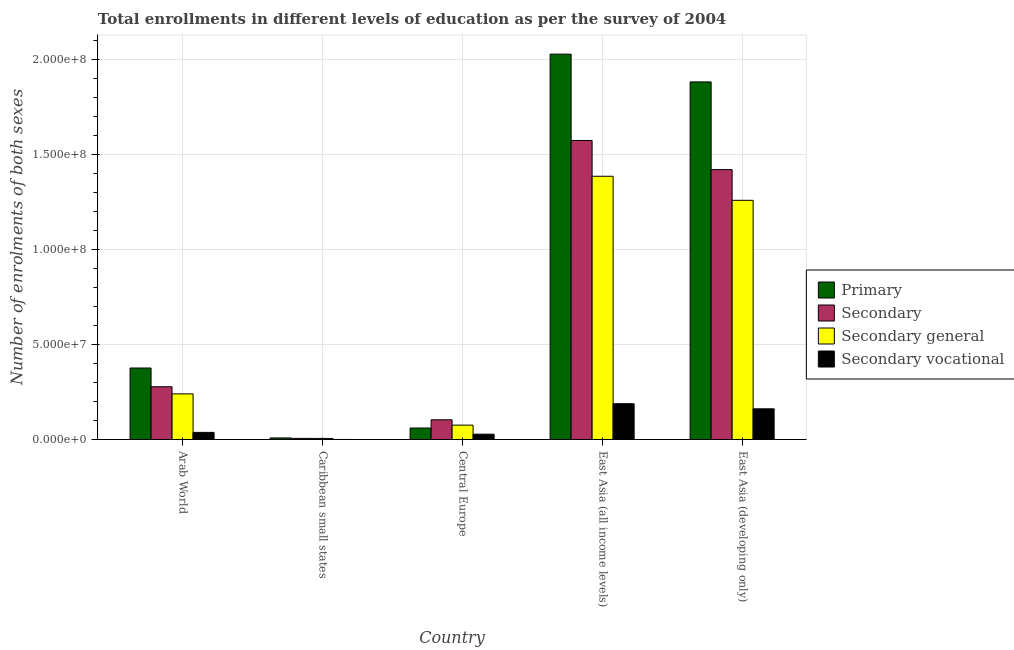Are the number of bars per tick equal to the number of legend labels?
Provide a succinct answer. Yes. How many bars are there on the 4th tick from the left?
Provide a succinct answer. 4. What is the label of the 3rd group of bars from the left?
Offer a terse response. Central Europe. In how many cases, is the number of bars for a given country not equal to the number of legend labels?
Your answer should be compact. 0. What is the number of enrolments in secondary education in Central Europe?
Your answer should be very brief. 1.04e+07. Across all countries, what is the maximum number of enrolments in secondary vocational education?
Your answer should be very brief. 1.88e+07. Across all countries, what is the minimum number of enrolments in secondary vocational education?
Your response must be concise. 3.11e+04. In which country was the number of enrolments in secondary vocational education maximum?
Make the answer very short. East Asia (all income levels). In which country was the number of enrolments in secondary education minimum?
Your answer should be very brief. Caribbean small states. What is the total number of enrolments in secondary education in the graph?
Your response must be concise. 3.38e+08. What is the difference between the number of enrolments in secondary general education in Central Europe and that in East Asia (all income levels)?
Provide a succinct answer. -1.31e+08. What is the difference between the number of enrolments in secondary general education in East Asia (all income levels) and the number of enrolments in secondary education in Arab World?
Provide a short and direct response. 1.11e+08. What is the average number of enrolments in primary education per country?
Ensure brevity in your answer.  8.71e+07. What is the difference between the number of enrolments in secondary vocational education and number of enrolments in primary education in Caribbean small states?
Make the answer very short. -8.08e+05. What is the ratio of the number of enrolments in secondary education in Caribbean small states to that in East Asia (all income levels)?
Provide a succinct answer. 0. Is the number of enrolments in primary education in Central Europe less than that in East Asia (developing only)?
Keep it short and to the point. Yes. What is the difference between the highest and the second highest number of enrolments in secondary vocational education?
Your response must be concise. 2.68e+06. What is the difference between the highest and the lowest number of enrolments in secondary education?
Provide a succinct answer. 1.57e+08. Is it the case that in every country, the sum of the number of enrolments in primary education and number of enrolments in secondary general education is greater than the sum of number of enrolments in secondary education and number of enrolments in secondary vocational education?
Keep it short and to the point. No. What does the 3rd bar from the left in Arab World represents?
Give a very brief answer. Secondary general. What does the 1st bar from the right in Central Europe represents?
Make the answer very short. Secondary vocational. Is it the case that in every country, the sum of the number of enrolments in primary education and number of enrolments in secondary education is greater than the number of enrolments in secondary general education?
Offer a very short reply. Yes. Are all the bars in the graph horizontal?
Your answer should be compact. No. Where does the legend appear in the graph?
Your answer should be compact. Center right. What is the title of the graph?
Give a very brief answer. Total enrollments in different levels of education as per the survey of 2004. Does "Secondary schools" appear as one of the legend labels in the graph?
Provide a succinct answer. No. What is the label or title of the X-axis?
Your answer should be compact. Country. What is the label or title of the Y-axis?
Your response must be concise. Number of enrolments of both sexes. What is the Number of enrolments of both sexes in Primary in Arab World?
Keep it short and to the point. 3.76e+07. What is the Number of enrolments of both sexes in Secondary in Arab World?
Make the answer very short. 2.78e+07. What is the Number of enrolments of both sexes of Secondary general in Arab World?
Provide a short and direct response. 2.40e+07. What is the Number of enrolments of both sexes of Secondary vocational in Arab World?
Your response must be concise. 3.75e+06. What is the Number of enrolments of both sexes in Primary in Caribbean small states?
Make the answer very short. 8.39e+05. What is the Number of enrolments of both sexes in Secondary in Caribbean small states?
Your answer should be very brief. 5.95e+05. What is the Number of enrolments of both sexes in Secondary general in Caribbean small states?
Ensure brevity in your answer.  5.64e+05. What is the Number of enrolments of both sexes of Secondary vocational in Caribbean small states?
Your answer should be very brief. 3.11e+04. What is the Number of enrolments of both sexes of Primary in Central Europe?
Ensure brevity in your answer.  6.05e+06. What is the Number of enrolments of both sexes of Secondary in Central Europe?
Offer a very short reply. 1.04e+07. What is the Number of enrolments of both sexes of Secondary general in Central Europe?
Keep it short and to the point. 7.57e+06. What is the Number of enrolments of both sexes of Secondary vocational in Central Europe?
Keep it short and to the point. 2.81e+06. What is the Number of enrolments of both sexes in Primary in East Asia (all income levels)?
Offer a very short reply. 2.03e+08. What is the Number of enrolments of both sexes in Secondary in East Asia (all income levels)?
Make the answer very short. 1.57e+08. What is the Number of enrolments of both sexes of Secondary general in East Asia (all income levels)?
Your answer should be very brief. 1.39e+08. What is the Number of enrolments of both sexes of Secondary vocational in East Asia (all income levels)?
Give a very brief answer. 1.88e+07. What is the Number of enrolments of both sexes of Primary in East Asia (developing only)?
Give a very brief answer. 1.88e+08. What is the Number of enrolments of both sexes of Secondary in East Asia (developing only)?
Your answer should be compact. 1.42e+08. What is the Number of enrolments of both sexes in Secondary general in East Asia (developing only)?
Your answer should be compact. 1.26e+08. What is the Number of enrolments of both sexes of Secondary vocational in East Asia (developing only)?
Provide a succinct answer. 1.62e+07. Across all countries, what is the maximum Number of enrolments of both sexes in Primary?
Offer a terse response. 2.03e+08. Across all countries, what is the maximum Number of enrolments of both sexes of Secondary?
Provide a succinct answer. 1.57e+08. Across all countries, what is the maximum Number of enrolments of both sexes of Secondary general?
Keep it short and to the point. 1.39e+08. Across all countries, what is the maximum Number of enrolments of both sexes of Secondary vocational?
Your answer should be compact. 1.88e+07. Across all countries, what is the minimum Number of enrolments of both sexes of Primary?
Make the answer very short. 8.39e+05. Across all countries, what is the minimum Number of enrolments of both sexes of Secondary?
Your answer should be very brief. 5.95e+05. Across all countries, what is the minimum Number of enrolments of both sexes in Secondary general?
Make the answer very short. 5.64e+05. Across all countries, what is the minimum Number of enrolments of both sexes in Secondary vocational?
Your response must be concise. 3.11e+04. What is the total Number of enrolments of both sexes in Primary in the graph?
Your answer should be compact. 4.35e+08. What is the total Number of enrolments of both sexes of Secondary in the graph?
Provide a succinct answer. 3.38e+08. What is the total Number of enrolments of both sexes in Secondary general in the graph?
Provide a succinct answer. 2.97e+08. What is the total Number of enrolments of both sexes of Secondary vocational in the graph?
Give a very brief answer. 4.16e+07. What is the difference between the Number of enrolments of both sexes in Primary in Arab World and that in Caribbean small states?
Give a very brief answer. 3.68e+07. What is the difference between the Number of enrolments of both sexes in Secondary in Arab World and that in Caribbean small states?
Your answer should be very brief. 2.72e+07. What is the difference between the Number of enrolments of both sexes in Secondary general in Arab World and that in Caribbean small states?
Offer a very short reply. 2.35e+07. What is the difference between the Number of enrolments of both sexes of Secondary vocational in Arab World and that in Caribbean small states?
Offer a very short reply. 3.72e+06. What is the difference between the Number of enrolments of both sexes of Primary in Arab World and that in Central Europe?
Make the answer very short. 3.16e+07. What is the difference between the Number of enrolments of both sexes in Secondary in Arab World and that in Central Europe?
Provide a succinct answer. 1.74e+07. What is the difference between the Number of enrolments of both sexes of Secondary general in Arab World and that in Central Europe?
Give a very brief answer. 1.65e+07. What is the difference between the Number of enrolments of both sexes of Secondary vocational in Arab World and that in Central Europe?
Offer a terse response. 9.45e+05. What is the difference between the Number of enrolments of both sexes in Primary in Arab World and that in East Asia (all income levels)?
Provide a succinct answer. -1.65e+08. What is the difference between the Number of enrolments of both sexes in Secondary in Arab World and that in East Asia (all income levels)?
Your answer should be very brief. -1.30e+08. What is the difference between the Number of enrolments of both sexes in Secondary general in Arab World and that in East Asia (all income levels)?
Provide a short and direct response. -1.14e+08. What is the difference between the Number of enrolments of both sexes in Secondary vocational in Arab World and that in East Asia (all income levels)?
Provide a short and direct response. -1.51e+07. What is the difference between the Number of enrolments of both sexes in Primary in Arab World and that in East Asia (developing only)?
Offer a terse response. -1.51e+08. What is the difference between the Number of enrolments of both sexes in Secondary in Arab World and that in East Asia (developing only)?
Give a very brief answer. -1.14e+08. What is the difference between the Number of enrolments of both sexes in Secondary general in Arab World and that in East Asia (developing only)?
Provide a succinct answer. -1.02e+08. What is the difference between the Number of enrolments of both sexes in Secondary vocational in Arab World and that in East Asia (developing only)?
Provide a short and direct response. -1.24e+07. What is the difference between the Number of enrolments of both sexes in Primary in Caribbean small states and that in Central Europe?
Give a very brief answer. -5.21e+06. What is the difference between the Number of enrolments of both sexes in Secondary in Caribbean small states and that in Central Europe?
Provide a short and direct response. -9.78e+06. What is the difference between the Number of enrolments of both sexes of Secondary general in Caribbean small states and that in Central Europe?
Offer a terse response. -7.01e+06. What is the difference between the Number of enrolments of both sexes in Secondary vocational in Caribbean small states and that in Central Europe?
Keep it short and to the point. -2.78e+06. What is the difference between the Number of enrolments of both sexes in Primary in Caribbean small states and that in East Asia (all income levels)?
Your response must be concise. -2.02e+08. What is the difference between the Number of enrolments of both sexes of Secondary in Caribbean small states and that in East Asia (all income levels)?
Your response must be concise. -1.57e+08. What is the difference between the Number of enrolments of both sexes in Secondary general in Caribbean small states and that in East Asia (all income levels)?
Your answer should be very brief. -1.38e+08. What is the difference between the Number of enrolments of both sexes in Secondary vocational in Caribbean small states and that in East Asia (all income levels)?
Offer a terse response. -1.88e+07. What is the difference between the Number of enrolments of both sexes of Primary in Caribbean small states and that in East Asia (developing only)?
Your answer should be very brief. -1.87e+08. What is the difference between the Number of enrolments of both sexes in Secondary in Caribbean small states and that in East Asia (developing only)?
Keep it short and to the point. -1.41e+08. What is the difference between the Number of enrolments of both sexes of Secondary general in Caribbean small states and that in East Asia (developing only)?
Make the answer very short. -1.25e+08. What is the difference between the Number of enrolments of both sexes in Secondary vocational in Caribbean small states and that in East Asia (developing only)?
Ensure brevity in your answer.  -1.61e+07. What is the difference between the Number of enrolments of both sexes in Primary in Central Europe and that in East Asia (all income levels)?
Make the answer very short. -1.97e+08. What is the difference between the Number of enrolments of both sexes of Secondary in Central Europe and that in East Asia (all income levels)?
Provide a short and direct response. -1.47e+08. What is the difference between the Number of enrolments of both sexes in Secondary general in Central Europe and that in East Asia (all income levels)?
Provide a succinct answer. -1.31e+08. What is the difference between the Number of enrolments of both sexes in Secondary vocational in Central Europe and that in East Asia (all income levels)?
Provide a short and direct response. -1.60e+07. What is the difference between the Number of enrolments of both sexes in Primary in Central Europe and that in East Asia (developing only)?
Your answer should be very brief. -1.82e+08. What is the difference between the Number of enrolments of both sexes in Secondary in Central Europe and that in East Asia (developing only)?
Offer a very short reply. -1.32e+08. What is the difference between the Number of enrolments of both sexes in Secondary general in Central Europe and that in East Asia (developing only)?
Your response must be concise. -1.18e+08. What is the difference between the Number of enrolments of both sexes of Secondary vocational in Central Europe and that in East Asia (developing only)?
Ensure brevity in your answer.  -1.33e+07. What is the difference between the Number of enrolments of both sexes in Primary in East Asia (all income levels) and that in East Asia (developing only)?
Your answer should be very brief. 1.46e+07. What is the difference between the Number of enrolments of both sexes of Secondary in East Asia (all income levels) and that in East Asia (developing only)?
Ensure brevity in your answer.  1.53e+07. What is the difference between the Number of enrolments of both sexes in Secondary general in East Asia (all income levels) and that in East Asia (developing only)?
Your answer should be very brief. 1.27e+07. What is the difference between the Number of enrolments of both sexes in Secondary vocational in East Asia (all income levels) and that in East Asia (developing only)?
Your answer should be very brief. 2.68e+06. What is the difference between the Number of enrolments of both sexes of Primary in Arab World and the Number of enrolments of both sexes of Secondary in Caribbean small states?
Provide a succinct answer. 3.70e+07. What is the difference between the Number of enrolments of both sexes of Primary in Arab World and the Number of enrolments of both sexes of Secondary general in Caribbean small states?
Provide a short and direct response. 3.71e+07. What is the difference between the Number of enrolments of both sexes of Primary in Arab World and the Number of enrolments of both sexes of Secondary vocational in Caribbean small states?
Provide a succinct answer. 3.76e+07. What is the difference between the Number of enrolments of both sexes in Secondary in Arab World and the Number of enrolments of both sexes in Secondary general in Caribbean small states?
Ensure brevity in your answer.  2.72e+07. What is the difference between the Number of enrolments of both sexes in Secondary in Arab World and the Number of enrolments of both sexes in Secondary vocational in Caribbean small states?
Make the answer very short. 2.77e+07. What is the difference between the Number of enrolments of both sexes of Secondary general in Arab World and the Number of enrolments of both sexes of Secondary vocational in Caribbean small states?
Your answer should be very brief. 2.40e+07. What is the difference between the Number of enrolments of both sexes in Primary in Arab World and the Number of enrolments of both sexes in Secondary in Central Europe?
Offer a very short reply. 2.72e+07. What is the difference between the Number of enrolments of both sexes in Primary in Arab World and the Number of enrolments of both sexes in Secondary general in Central Europe?
Give a very brief answer. 3.01e+07. What is the difference between the Number of enrolments of both sexes of Primary in Arab World and the Number of enrolments of both sexes of Secondary vocational in Central Europe?
Give a very brief answer. 3.48e+07. What is the difference between the Number of enrolments of both sexes of Secondary in Arab World and the Number of enrolments of both sexes of Secondary general in Central Europe?
Make the answer very short. 2.02e+07. What is the difference between the Number of enrolments of both sexes of Secondary in Arab World and the Number of enrolments of both sexes of Secondary vocational in Central Europe?
Offer a terse response. 2.50e+07. What is the difference between the Number of enrolments of both sexes in Secondary general in Arab World and the Number of enrolments of both sexes in Secondary vocational in Central Europe?
Keep it short and to the point. 2.12e+07. What is the difference between the Number of enrolments of both sexes of Primary in Arab World and the Number of enrolments of both sexes of Secondary in East Asia (all income levels)?
Your response must be concise. -1.20e+08. What is the difference between the Number of enrolments of both sexes in Primary in Arab World and the Number of enrolments of both sexes in Secondary general in East Asia (all income levels)?
Your response must be concise. -1.01e+08. What is the difference between the Number of enrolments of both sexes in Primary in Arab World and the Number of enrolments of both sexes in Secondary vocational in East Asia (all income levels)?
Offer a terse response. 1.88e+07. What is the difference between the Number of enrolments of both sexes of Secondary in Arab World and the Number of enrolments of both sexes of Secondary general in East Asia (all income levels)?
Keep it short and to the point. -1.11e+08. What is the difference between the Number of enrolments of both sexes of Secondary in Arab World and the Number of enrolments of both sexes of Secondary vocational in East Asia (all income levels)?
Your answer should be very brief. 8.94e+06. What is the difference between the Number of enrolments of both sexes in Secondary general in Arab World and the Number of enrolments of both sexes in Secondary vocational in East Asia (all income levels)?
Your answer should be compact. 5.19e+06. What is the difference between the Number of enrolments of both sexes of Primary in Arab World and the Number of enrolments of both sexes of Secondary in East Asia (developing only)?
Ensure brevity in your answer.  -1.04e+08. What is the difference between the Number of enrolments of both sexes in Primary in Arab World and the Number of enrolments of both sexes in Secondary general in East Asia (developing only)?
Provide a short and direct response. -8.82e+07. What is the difference between the Number of enrolments of both sexes of Primary in Arab World and the Number of enrolments of both sexes of Secondary vocational in East Asia (developing only)?
Your response must be concise. 2.15e+07. What is the difference between the Number of enrolments of both sexes of Secondary in Arab World and the Number of enrolments of both sexes of Secondary general in East Asia (developing only)?
Ensure brevity in your answer.  -9.81e+07. What is the difference between the Number of enrolments of both sexes of Secondary in Arab World and the Number of enrolments of both sexes of Secondary vocational in East Asia (developing only)?
Your answer should be very brief. 1.16e+07. What is the difference between the Number of enrolments of both sexes of Secondary general in Arab World and the Number of enrolments of both sexes of Secondary vocational in East Asia (developing only)?
Provide a short and direct response. 7.87e+06. What is the difference between the Number of enrolments of both sexes of Primary in Caribbean small states and the Number of enrolments of both sexes of Secondary in Central Europe?
Provide a succinct answer. -9.54e+06. What is the difference between the Number of enrolments of both sexes in Primary in Caribbean small states and the Number of enrolments of both sexes in Secondary general in Central Europe?
Your answer should be compact. -6.73e+06. What is the difference between the Number of enrolments of both sexes of Primary in Caribbean small states and the Number of enrolments of both sexes of Secondary vocational in Central Europe?
Give a very brief answer. -1.97e+06. What is the difference between the Number of enrolments of both sexes of Secondary in Caribbean small states and the Number of enrolments of both sexes of Secondary general in Central Europe?
Your answer should be very brief. -6.98e+06. What is the difference between the Number of enrolments of both sexes in Secondary in Caribbean small states and the Number of enrolments of both sexes in Secondary vocational in Central Europe?
Ensure brevity in your answer.  -2.21e+06. What is the difference between the Number of enrolments of both sexes of Secondary general in Caribbean small states and the Number of enrolments of both sexes of Secondary vocational in Central Europe?
Provide a succinct answer. -2.24e+06. What is the difference between the Number of enrolments of both sexes of Primary in Caribbean small states and the Number of enrolments of both sexes of Secondary in East Asia (all income levels)?
Give a very brief answer. -1.57e+08. What is the difference between the Number of enrolments of both sexes of Primary in Caribbean small states and the Number of enrolments of both sexes of Secondary general in East Asia (all income levels)?
Provide a short and direct response. -1.38e+08. What is the difference between the Number of enrolments of both sexes in Primary in Caribbean small states and the Number of enrolments of both sexes in Secondary vocational in East Asia (all income levels)?
Provide a short and direct response. -1.80e+07. What is the difference between the Number of enrolments of both sexes in Secondary in Caribbean small states and the Number of enrolments of both sexes in Secondary general in East Asia (all income levels)?
Offer a terse response. -1.38e+08. What is the difference between the Number of enrolments of both sexes in Secondary in Caribbean small states and the Number of enrolments of both sexes in Secondary vocational in East Asia (all income levels)?
Provide a succinct answer. -1.82e+07. What is the difference between the Number of enrolments of both sexes in Secondary general in Caribbean small states and the Number of enrolments of both sexes in Secondary vocational in East Asia (all income levels)?
Give a very brief answer. -1.83e+07. What is the difference between the Number of enrolments of both sexes of Primary in Caribbean small states and the Number of enrolments of both sexes of Secondary in East Asia (developing only)?
Ensure brevity in your answer.  -1.41e+08. What is the difference between the Number of enrolments of both sexes of Primary in Caribbean small states and the Number of enrolments of both sexes of Secondary general in East Asia (developing only)?
Provide a succinct answer. -1.25e+08. What is the difference between the Number of enrolments of both sexes of Primary in Caribbean small states and the Number of enrolments of both sexes of Secondary vocational in East Asia (developing only)?
Provide a succinct answer. -1.53e+07. What is the difference between the Number of enrolments of both sexes in Secondary in Caribbean small states and the Number of enrolments of both sexes in Secondary general in East Asia (developing only)?
Offer a terse response. -1.25e+08. What is the difference between the Number of enrolments of both sexes in Secondary in Caribbean small states and the Number of enrolments of both sexes in Secondary vocational in East Asia (developing only)?
Ensure brevity in your answer.  -1.56e+07. What is the difference between the Number of enrolments of both sexes in Secondary general in Caribbean small states and the Number of enrolments of both sexes in Secondary vocational in East Asia (developing only)?
Your response must be concise. -1.56e+07. What is the difference between the Number of enrolments of both sexes of Primary in Central Europe and the Number of enrolments of both sexes of Secondary in East Asia (all income levels)?
Your answer should be compact. -1.51e+08. What is the difference between the Number of enrolments of both sexes in Primary in Central Europe and the Number of enrolments of both sexes in Secondary general in East Asia (all income levels)?
Provide a short and direct response. -1.32e+08. What is the difference between the Number of enrolments of both sexes in Primary in Central Europe and the Number of enrolments of both sexes in Secondary vocational in East Asia (all income levels)?
Give a very brief answer. -1.28e+07. What is the difference between the Number of enrolments of both sexes in Secondary in Central Europe and the Number of enrolments of both sexes in Secondary general in East Asia (all income levels)?
Offer a terse response. -1.28e+08. What is the difference between the Number of enrolments of both sexes of Secondary in Central Europe and the Number of enrolments of both sexes of Secondary vocational in East Asia (all income levels)?
Offer a very short reply. -8.46e+06. What is the difference between the Number of enrolments of both sexes of Secondary general in Central Europe and the Number of enrolments of both sexes of Secondary vocational in East Asia (all income levels)?
Keep it short and to the point. -1.13e+07. What is the difference between the Number of enrolments of both sexes in Primary in Central Europe and the Number of enrolments of both sexes in Secondary in East Asia (developing only)?
Provide a succinct answer. -1.36e+08. What is the difference between the Number of enrolments of both sexes of Primary in Central Europe and the Number of enrolments of both sexes of Secondary general in East Asia (developing only)?
Offer a very short reply. -1.20e+08. What is the difference between the Number of enrolments of both sexes in Primary in Central Europe and the Number of enrolments of both sexes in Secondary vocational in East Asia (developing only)?
Offer a terse response. -1.01e+07. What is the difference between the Number of enrolments of both sexes of Secondary in Central Europe and the Number of enrolments of both sexes of Secondary general in East Asia (developing only)?
Provide a succinct answer. -1.15e+08. What is the difference between the Number of enrolments of both sexes of Secondary in Central Europe and the Number of enrolments of both sexes of Secondary vocational in East Asia (developing only)?
Your response must be concise. -5.78e+06. What is the difference between the Number of enrolments of both sexes in Secondary general in Central Europe and the Number of enrolments of both sexes in Secondary vocational in East Asia (developing only)?
Offer a very short reply. -8.58e+06. What is the difference between the Number of enrolments of both sexes of Primary in East Asia (all income levels) and the Number of enrolments of both sexes of Secondary in East Asia (developing only)?
Your answer should be very brief. 6.08e+07. What is the difference between the Number of enrolments of both sexes of Primary in East Asia (all income levels) and the Number of enrolments of both sexes of Secondary general in East Asia (developing only)?
Offer a terse response. 7.69e+07. What is the difference between the Number of enrolments of both sexes in Primary in East Asia (all income levels) and the Number of enrolments of both sexes in Secondary vocational in East Asia (developing only)?
Your answer should be compact. 1.87e+08. What is the difference between the Number of enrolments of both sexes of Secondary in East Asia (all income levels) and the Number of enrolments of both sexes of Secondary general in East Asia (developing only)?
Offer a very short reply. 3.15e+07. What is the difference between the Number of enrolments of both sexes of Secondary in East Asia (all income levels) and the Number of enrolments of both sexes of Secondary vocational in East Asia (developing only)?
Make the answer very short. 1.41e+08. What is the difference between the Number of enrolments of both sexes in Secondary general in East Asia (all income levels) and the Number of enrolments of both sexes in Secondary vocational in East Asia (developing only)?
Your answer should be very brief. 1.22e+08. What is the average Number of enrolments of both sexes of Primary per country?
Provide a short and direct response. 8.71e+07. What is the average Number of enrolments of both sexes in Secondary per country?
Give a very brief answer. 6.76e+07. What is the average Number of enrolments of both sexes in Secondary general per country?
Give a very brief answer. 5.93e+07. What is the average Number of enrolments of both sexes of Secondary vocational per country?
Give a very brief answer. 8.32e+06. What is the difference between the Number of enrolments of both sexes in Primary and Number of enrolments of both sexes in Secondary in Arab World?
Keep it short and to the point. 9.85e+06. What is the difference between the Number of enrolments of both sexes of Primary and Number of enrolments of both sexes of Secondary general in Arab World?
Offer a terse response. 1.36e+07. What is the difference between the Number of enrolments of both sexes in Primary and Number of enrolments of both sexes in Secondary vocational in Arab World?
Your answer should be compact. 3.39e+07. What is the difference between the Number of enrolments of both sexes of Secondary and Number of enrolments of both sexes of Secondary general in Arab World?
Provide a short and direct response. 3.75e+06. What is the difference between the Number of enrolments of both sexes in Secondary and Number of enrolments of both sexes in Secondary vocational in Arab World?
Your answer should be very brief. 2.40e+07. What is the difference between the Number of enrolments of both sexes of Secondary general and Number of enrolments of both sexes of Secondary vocational in Arab World?
Offer a very short reply. 2.03e+07. What is the difference between the Number of enrolments of both sexes of Primary and Number of enrolments of both sexes of Secondary in Caribbean small states?
Ensure brevity in your answer.  2.44e+05. What is the difference between the Number of enrolments of both sexes of Primary and Number of enrolments of both sexes of Secondary general in Caribbean small states?
Provide a succinct answer. 2.75e+05. What is the difference between the Number of enrolments of both sexes of Primary and Number of enrolments of both sexes of Secondary vocational in Caribbean small states?
Ensure brevity in your answer.  8.08e+05. What is the difference between the Number of enrolments of both sexes in Secondary and Number of enrolments of both sexes in Secondary general in Caribbean small states?
Give a very brief answer. 3.11e+04. What is the difference between the Number of enrolments of both sexes in Secondary and Number of enrolments of both sexes in Secondary vocational in Caribbean small states?
Provide a short and direct response. 5.64e+05. What is the difference between the Number of enrolments of both sexes of Secondary general and Number of enrolments of both sexes of Secondary vocational in Caribbean small states?
Give a very brief answer. 5.33e+05. What is the difference between the Number of enrolments of both sexes of Primary and Number of enrolments of both sexes of Secondary in Central Europe?
Provide a short and direct response. -4.33e+06. What is the difference between the Number of enrolments of both sexes of Primary and Number of enrolments of both sexes of Secondary general in Central Europe?
Provide a short and direct response. -1.52e+06. What is the difference between the Number of enrolments of both sexes of Primary and Number of enrolments of both sexes of Secondary vocational in Central Europe?
Your answer should be very brief. 3.25e+06. What is the difference between the Number of enrolments of both sexes of Secondary and Number of enrolments of both sexes of Secondary general in Central Europe?
Keep it short and to the point. 2.81e+06. What is the difference between the Number of enrolments of both sexes in Secondary and Number of enrolments of both sexes in Secondary vocational in Central Europe?
Provide a short and direct response. 7.57e+06. What is the difference between the Number of enrolments of both sexes in Secondary general and Number of enrolments of both sexes in Secondary vocational in Central Europe?
Your answer should be very brief. 4.76e+06. What is the difference between the Number of enrolments of both sexes in Primary and Number of enrolments of both sexes in Secondary in East Asia (all income levels)?
Provide a short and direct response. 4.54e+07. What is the difference between the Number of enrolments of both sexes in Primary and Number of enrolments of both sexes in Secondary general in East Asia (all income levels)?
Ensure brevity in your answer.  6.43e+07. What is the difference between the Number of enrolments of both sexes of Primary and Number of enrolments of both sexes of Secondary vocational in East Asia (all income levels)?
Your answer should be very brief. 1.84e+08. What is the difference between the Number of enrolments of both sexes of Secondary and Number of enrolments of both sexes of Secondary general in East Asia (all income levels)?
Keep it short and to the point. 1.88e+07. What is the difference between the Number of enrolments of both sexes of Secondary and Number of enrolments of both sexes of Secondary vocational in East Asia (all income levels)?
Your response must be concise. 1.39e+08. What is the difference between the Number of enrolments of both sexes in Secondary general and Number of enrolments of both sexes in Secondary vocational in East Asia (all income levels)?
Provide a short and direct response. 1.20e+08. What is the difference between the Number of enrolments of both sexes of Primary and Number of enrolments of both sexes of Secondary in East Asia (developing only)?
Give a very brief answer. 4.61e+07. What is the difference between the Number of enrolments of both sexes of Primary and Number of enrolments of both sexes of Secondary general in East Asia (developing only)?
Ensure brevity in your answer.  6.23e+07. What is the difference between the Number of enrolments of both sexes of Primary and Number of enrolments of both sexes of Secondary vocational in East Asia (developing only)?
Provide a short and direct response. 1.72e+08. What is the difference between the Number of enrolments of both sexes of Secondary and Number of enrolments of both sexes of Secondary general in East Asia (developing only)?
Give a very brief answer. 1.62e+07. What is the difference between the Number of enrolments of both sexes in Secondary and Number of enrolments of both sexes in Secondary vocational in East Asia (developing only)?
Provide a succinct answer. 1.26e+08. What is the difference between the Number of enrolments of both sexes in Secondary general and Number of enrolments of both sexes in Secondary vocational in East Asia (developing only)?
Provide a short and direct response. 1.10e+08. What is the ratio of the Number of enrolments of both sexes of Primary in Arab World to that in Caribbean small states?
Offer a very short reply. 44.84. What is the ratio of the Number of enrolments of both sexes of Secondary in Arab World to that in Caribbean small states?
Make the answer very short. 46.65. What is the ratio of the Number of enrolments of both sexes of Secondary general in Arab World to that in Caribbean small states?
Offer a terse response. 42.58. What is the ratio of the Number of enrolments of both sexes in Secondary vocational in Arab World to that in Caribbean small states?
Your answer should be compact. 120.49. What is the ratio of the Number of enrolments of both sexes in Primary in Arab World to that in Central Europe?
Your answer should be compact. 6.22. What is the ratio of the Number of enrolments of both sexes of Secondary in Arab World to that in Central Europe?
Provide a succinct answer. 2.68. What is the ratio of the Number of enrolments of both sexes in Secondary general in Arab World to that in Central Europe?
Offer a terse response. 3.17. What is the ratio of the Number of enrolments of both sexes in Secondary vocational in Arab World to that in Central Europe?
Offer a terse response. 1.34. What is the ratio of the Number of enrolments of both sexes of Primary in Arab World to that in East Asia (all income levels)?
Your response must be concise. 0.19. What is the ratio of the Number of enrolments of both sexes in Secondary in Arab World to that in East Asia (all income levels)?
Ensure brevity in your answer.  0.18. What is the ratio of the Number of enrolments of both sexes in Secondary general in Arab World to that in East Asia (all income levels)?
Your response must be concise. 0.17. What is the ratio of the Number of enrolments of both sexes of Secondary vocational in Arab World to that in East Asia (all income levels)?
Offer a terse response. 0.2. What is the ratio of the Number of enrolments of both sexes of Secondary in Arab World to that in East Asia (developing only)?
Your answer should be very brief. 0.2. What is the ratio of the Number of enrolments of both sexes in Secondary general in Arab World to that in East Asia (developing only)?
Give a very brief answer. 0.19. What is the ratio of the Number of enrolments of both sexes of Secondary vocational in Arab World to that in East Asia (developing only)?
Your response must be concise. 0.23. What is the ratio of the Number of enrolments of both sexes of Primary in Caribbean small states to that in Central Europe?
Give a very brief answer. 0.14. What is the ratio of the Number of enrolments of both sexes of Secondary in Caribbean small states to that in Central Europe?
Give a very brief answer. 0.06. What is the ratio of the Number of enrolments of both sexes of Secondary general in Caribbean small states to that in Central Europe?
Give a very brief answer. 0.07. What is the ratio of the Number of enrolments of both sexes of Secondary vocational in Caribbean small states to that in Central Europe?
Your answer should be very brief. 0.01. What is the ratio of the Number of enrolments of both sexes in Primary in Caribbean small states to that in East Asia (all income levels)?
Provide a succinct answer. 0. What is the ratio of the Number of enrolments of both sexes of Secondary in Caribbean small states to that in East Asia (all income levels)?
Offer a very short reply. 0. What is the ratio of the Number of enrolments of both sexes of Secondary general in Caribbean small states to that in East Asia (all income levels)?
Keep it short and to the point. 0. What is the ratio of the Number of enrolments of both sexes of Secondary vocational in Caribbean small states to that in East Asia (all income levels)?
Provide a short and direct response. 0. What is the ratio of the Number of enrolments of both sexes in Primary in Caribbean small states to that in East Asia (developing only)?
Keep it short and to the point. 0. What is the ratio of the Number of enrolments of both sexes of Secondary in Caribbean small states to that in East Asia (developing only)?
Offer a terse response. 0. What is the ratio of the Number of enrolments of both sexes of Secondary general in Caribbean small states to that in East Asia (developing only)?
Ensure brevity in your answer.  0. What is the ratio of the Number of enrolments of both sexes in Secondary vocational in Caribbean small states to that in East Asia (developing only)?
Ensure brevity in your answer.  0. What is the ratio of the Number of enrolments of both sexes of Primary in Central Europe to that in East Asia (all income levels)?
Give a very brief answer. 0.03. What is the ratio of the Number of enrolments of both sexes in Secondary in Central Europe to that in East Asia (all income levels)?
Your answer should be very brief. 0.07. What is the ratio of the Number of enrolments of both sexes in Secondary general in Central Europe to that in East Asia (all income levels)?
Your answer should be very brief. 0.05. What is the ratio of the Number of enrolments of both sexes of Secondary vocational in Central Europe to that in East Asia (all income levels)?
Provide a short and direct response. 0.15. What is the ratio of the Number of enrolments of both sexes of Primary in Central Europe to that in East Asia (developing only)?
Offer a very short reply. 0.03. What is the ratio of the Number of enrolments of both sexes in Secondary in Central Europe to that in East Asia (developing only)?
Ensure brevity in your answer.  0.07. What is the ratio of the Number of enrolments of both sexes in Secondary general in Central Europe to that in East Asia (developing only)?
Offer a terse response. 0.06. What is the ratio of the Number of enrolments of both sexes of Secondary vocational in Central Europe to that in East Asia (developing only)?
Ensure brevity in your answer.  0.17. What is the ratio of the Number of enrolments of both sexes of Primary in East Asia (all income levels) to that in East Asia (developing only)?
Your answer should be compact. 1.08. What is the ratio of the Number of enrolments of both sexes in Secondary in East Asia (all income levels) to that in East Asia (developing only)?
Your answer should be compact. 1.11. What is the ratio of the Number of enrolments of both sexes of Secondary general in East Asia (all income levels) to that in East Asia (developing only)?
Provide a short and direct response. 1.1. What is the ratio of the Number of enrolments of both sexes of Secondary vocational in East Asia (all income levels) to that in East Asia (developing only)?
Your answer should be compact. 1.17. What is the difference between the highest and the second highest Number of enrolments of both sexes in Primary?
Your response must be concise. 1.46e+07. What is the difference between the highest and the second highest Number of enrolments of both sexes in Secondary?
Offer a terse response. 1.53e+07. What is the difference between the highest and the second highest Number of enrolments of both sexes in Secondary general?
Provide a succinct answer. 1.27e+07. What is the difference between the highest and the second highest Number of enrolments of both sexes in Secondary vocational?
Your response must be concise. 2.68e+06. What is the difference between the highest and the lowest Number of enrolments of both sexes of Primary?
Provide a short and direct response. 2.02e+08. What is the difference between the highest and the lowest Number of enrolments of both sexes in Secondary?
Keep it short and to the point. 1.57e+08. What is the difference between the highest and the lowest Number of enrolments of both sexes in Secondary general?
Provide a succinct answer. 1.38e+08. What is the difference between the highest and the lowest Number of enrolments of both sexes in Secondary vocational?
Your answer should be very brief. 1.88e+07. 